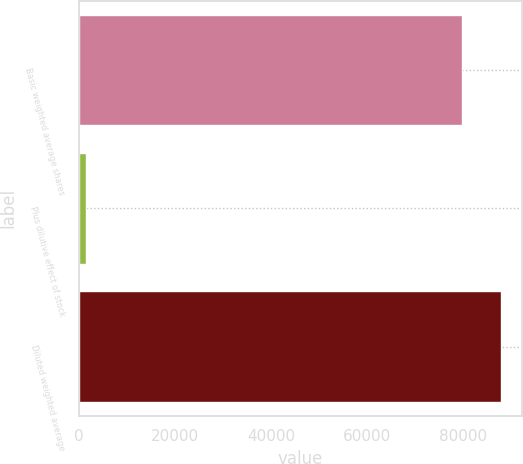Convert chart to OTSL. <chart><loc_0><loc_0><loc_500><loc_500><bar_chart><fcel>Basic weighted average shares<fcel>Plus dilutive effect of stock<fcel>Diluted weighted average<nl><fcel>79765<fcel>1371<fcel>87741.5<nl></chart> 